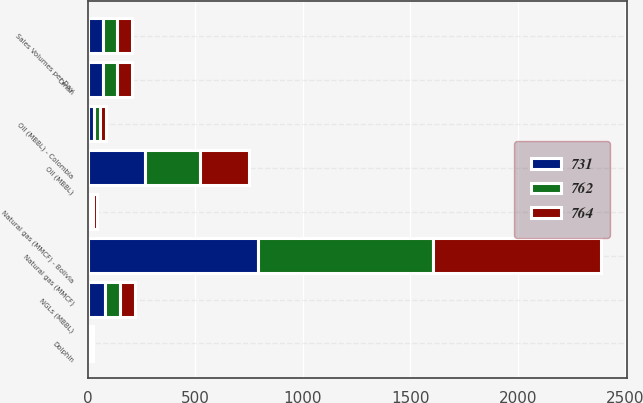Convert chart. <chart><loc_0><loc_0><loc_500><loc_500><stacked_bar_chart><ecel><fcel>Sales Volumes per Day<fcel>Oil (MBBL)<fcel>NGLs (MBBL)<fcel>Natural gas (MMCF)<fcel>Oil (MBBL) - Colombia<fcel>Natural gas (MMCF) - Bolivia<fcel>Dolphin<fcel>Oman<nl><fcel>731<fcel>68<fcel>266<fcel>77<fcel>789<fcel>27<fcel>12<fcel>6<fcel>68<nl><fcel>762<fcel>68<fcel>255<fcel>73<fcel>819<fcel>28<fcel>13<fcel>8<fcel>66<nl><fcel>764<fcel>68<fcel>230<fcel>69<fcel>782<fcel>29<fcel>15<fcel>9<fcel>69<nl></chart> 